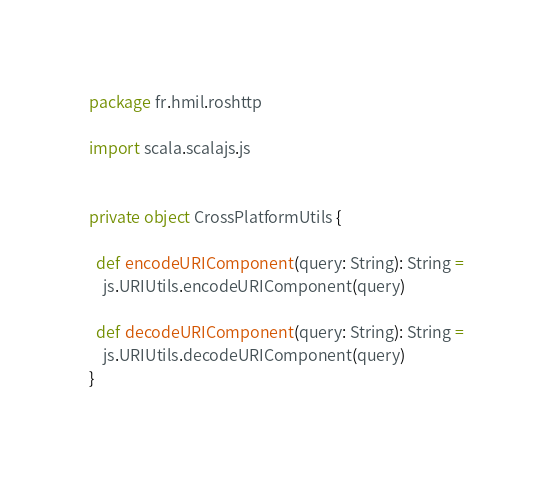Convert code to text. <code><loc_0><loc_0><loc_500><loc_500><_Scala_>package fr.hmil.roshttp

import scala.scalajs.js


private object CrossPlatformUtils {

  def encodeURIComponent(query: String): String =
    js.URIUtils.encodeURIComponent(query)

  def decodeURIComponent(query: String): String =
    js.URIUtils.decodeURIComponent(query)
}
</code> 